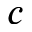<formula> <loc_0><loc_0><loc_500><loc_500>c</formula> 